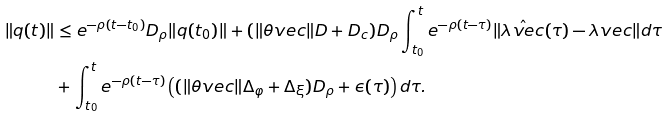Convert formula to latex. <formula><loc_0><loc_0><loc_500><loc_500>\| q ( t ) \| & \leq e ^ { - \rho ( t - t _ { 0 } ) } D _ { \rho } \| q ( t _ { 0 } ) \| + ( \| \theta v e c \| D + D _ { c } ) D _ { \rho } \int _ { t _ { 0 } } ^ { t } e ^ { - \rho ( t - \tau ) } \| \hat { \lambda v e c } ( \tau ) - \lambda v e c \| d \tau \\ & + \int _ { t _ { 0 } } ^ { t } e ^ { - \rho ( t - \tau ) } \left ( { ( \| \theta v e c \| \Delta _ { \varphi } + \Delta _ { \xi } ) D _ { \rho } } + \epsilon ( \tau ) \right ) d \tau .</formula> 